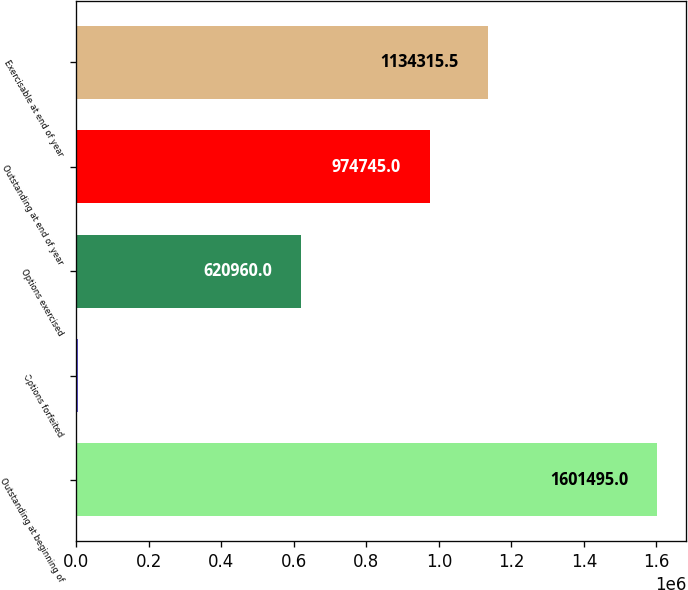Convert chart to OTSL. <chart><loc_0><loc_0><loc_500><loc_500><bar_chart><fcel>Outstanding at beginning of<fcel>Options forfeited<fcel>Options exercised<fcel>Outstanding at end of year<fcel>Exercisable at end of year<nl><fcel>1.6015e+06<fcel>5790<fcel>620960<fcel>974745<fcel>1.13432e+06<nl></chart> 